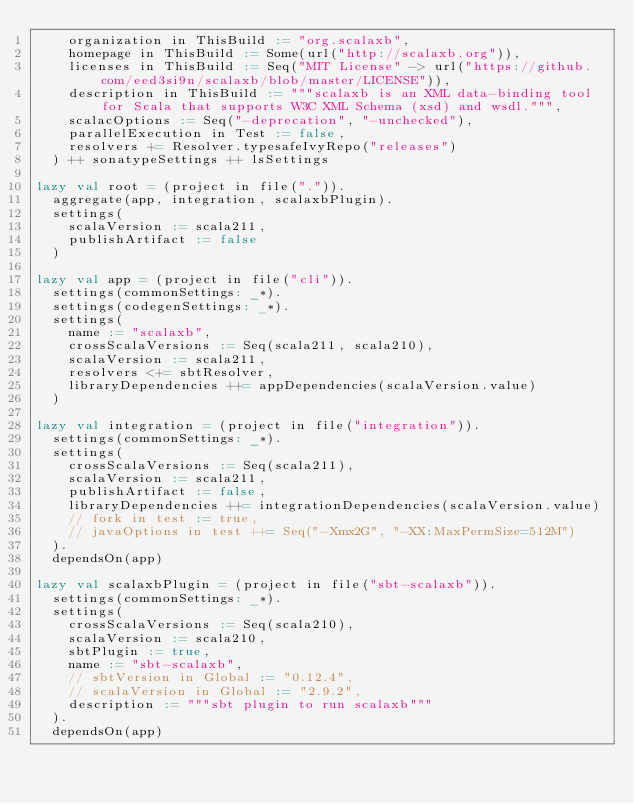Convert code to text. <code><loc_0><loc_0><loc_500><loc_500><_Scala_>    organization in ThisBuild := "org.scalaxb",
    homepage in ThisBuild := Some(url("http://scalaxb.org")),
    licenses in ThisBuild := Seq("MIT License" -> url("https://github.com/eed3si9n/scalaxb/blob/master/LICENSE")),
    description in ThisBuild := """scalaxb is an XML data-binding tool for Scala that supports W3C XML Schema (xsd) and wsdl.""",
    scalacOptions := Seq("-deprecation", "-unchecked"),
    parallelExecution in Test := false,
    resolvers += Resolver.typesafeIvyRepo("releases")
  ) ++ sonatypeSettings ++ lsSettings

lazy val root = (project in file(".")).
  aggregate(app, integration, scalaxbPlugin).
  settings(
    scalaVersion := scala211,
    publishArtifact := false
  )

lazy val app = (project in file("cli")).
  settings(commonSettings: _*).
  settings(codegenSettings: _*).
  settings(
    name := "scalaxb",
    crossScalaVersions := Seq(scala211, scala210),
    scalaVersion := scala211,
    resolvers <+= sbtResolver,
    libraryDependencies ++= appDependencies(scalaVersion.value)
  )

lazy val integration = (project in file("integration")).
  settings(commonSettings: _*).
  settings(
    crossScalaVersions := Seq(scala211),
    scalaVersion := scala211,
    publishArtifact := false,
    libraryDependencies ++= integrationDependencies(scalaVersion.value)
    // fork in test := true,
    // javaOptions in test ++= Seq("-Xmx2G", "-XX:MaxPermSize=512M")
  ).
  dependsOn(app)

lazy val scalaxbPlugin = (project in file("sbt-scalaxb")).
  settings(commonSettings: _*).
  settings(
    crossScalaVersions := Seq(scala210),
    scalaVersion := scala210,
    sbtPlugin := true,
    name := "sbt-scalaxb",
    // sbtVersion in Global := "0.12.4",
    // scalaVersion in Global := "2.9.2",
    description := """sbt plugin to run scalaxb"""
  ).
  dependsOn(app)
</code> 